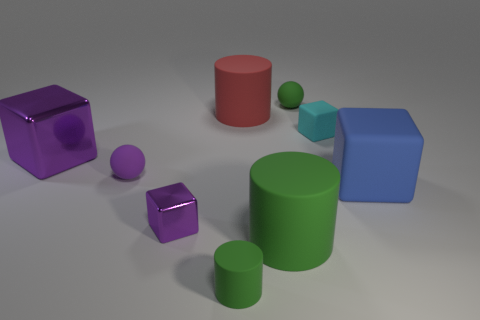Subtract all big rubber cylinders. How many cylinders are left? 1 Subtract all cyan blocks. How many blocks are left? 3 Add 1 big blue rubber cubes. How many objects exist? 10 Subtract all green blocks. Subtract all red spheres. How many blocks are left? 4 Subtract all spheres. How many objects are left? 7 Add 5 large purple metallic blocks. How many large purple metallic blocks are left? 6 Add 1 big blue rubber blocks. How many big blue rubber blocks exist? 2 Subtract 0 blue spheres. How many objects are left? 9 Subtract all big blocks. Subtract all large purple matte balls. How many objects are left? 7 